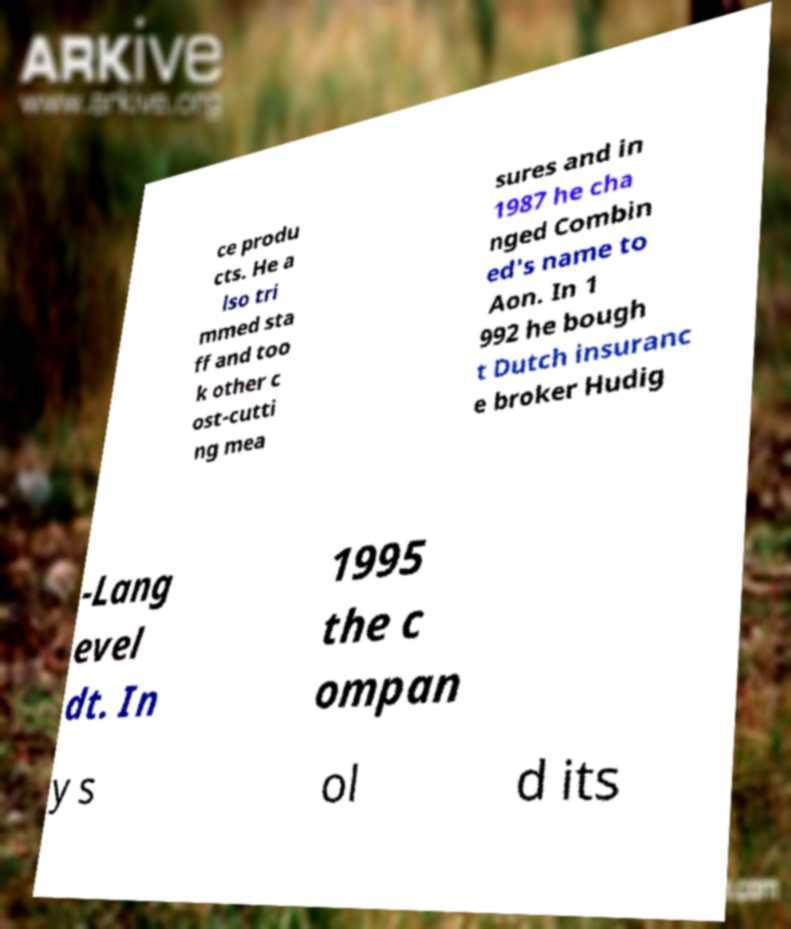Can you accurately transcribe the text from the provided image for me? ce produ cts. He a lso tri mmed sta ff and too k other c ost-cutti ng mea sures and in 1987 he cha nged Combin ed's name to Aon. In 1 992 he bough t Dutch insuranc e broker Hudig -Lang evel dt. In 1995 the c ompan y s ol d its 